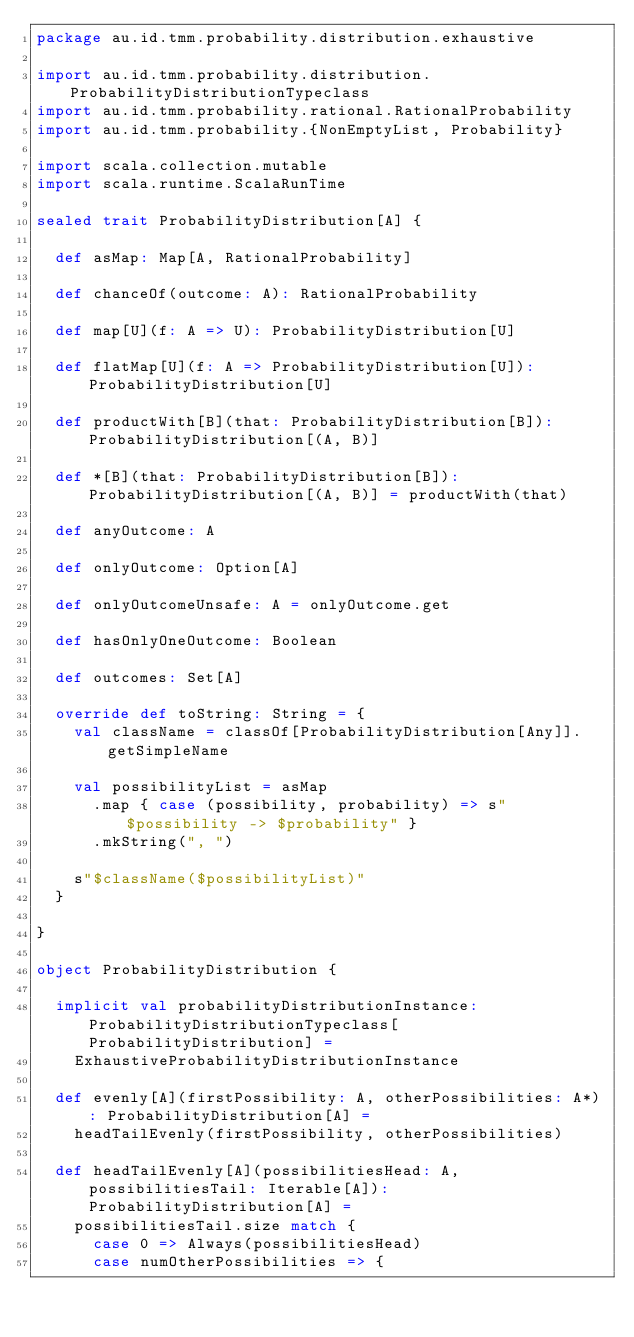<code> <loc_0><loc_0><loc_500><loc_500><_Scala_>package au.id.tmm.probability.distribution.exhaustive

import au.id.tmm.probability.distribution.ProbabilityDistributionTypeclass
import au.id.tmm.probability.rational.RationalProbability
import au.id.tmm.probability.{NonEmptyList, Probability}

import scala.collection.mutable
import scala.runtime.ScalaRunTime

sealed trait ProbabilityDistribution[A] {

  def asMap: Map[A, RationalProbability]

  def chanceOf(outcome: A): RationalProbability

  def map[U](f: A => U): ProbabilityDistribution[U]

  def flatMap[U](f: A => ProbabilityDistribution[U]): ProbabilityDistribution[U]

  def productWith[B](that: ProbabilityDistribution[B]): ProbabilityDistribution[(A, B)]

  def *[B](that: ProbabilityDistribution[B]): ProbabilityDistribution[(A, B)] = productWith(that)

  def anyOutcome: A

  def onlyOutcome: Option[A]

  def onlyOutcomeUnsafe: A = onlyOutcome.get

  def hasOnlyOneOutcome: Boolean

  def outcomes: Set[A]

  override def toString: String = {
    val className = classOf[ProbabilityDistribution[Any]].getSimpleName

    val possibilityList = asMap
      .map { case (possibility, probability) => s"$possibility -> $probability" }
      .mkString(", ")

    s"$className($possibilityList)"
  }

}

object ProbabilityDistribution {

  implicit val probabilityDistributionInstance: ProbabilityDistributionTypeclass[ProbabilityDistribution] =
    ExhaustiveProbabilityDistributionInstance

  def evenly[A](firstPossibility: A, otherPossibilities: A*): ProbabilityDistribution[A] =
    headTailEvenly(firstPossibility, otherPossibilities)

  def headTailEvenly[A](possibilitiesHead: A, possibilitiesTail: Iterable[A]): ProbabilityDistribution[A] =
    possibilitiesTail.size match {
      case 0 => Always(possibilitiesHead)
      case numOtherPossibilities => {</code> 